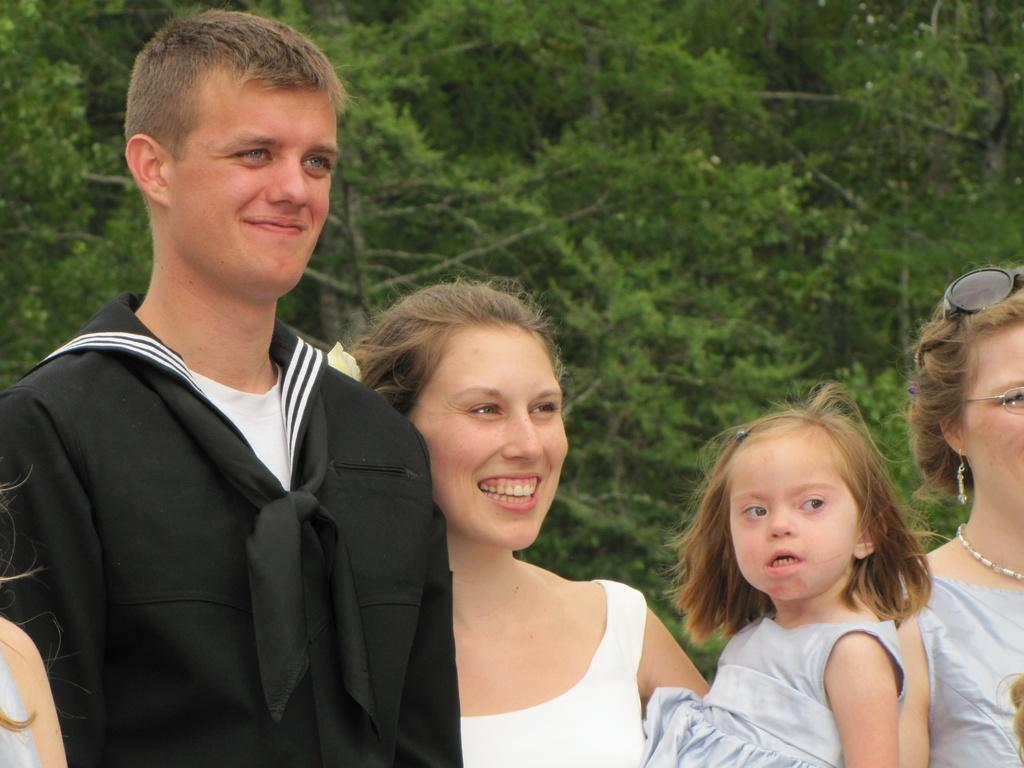What is happening with the group of people in the image? The people are standing and posing for a photo. How many people can be clearly seen in the image? There are five people in the image who are clearly visible. Is there anyone else in the image who is not clearly visible? Yes, one person is not clearly visible in the image. What type of spoon is being used by the person in the lunchroom in the image? There is no spoon or lunchroom present in the image; it features a group of people posing for a photo. 